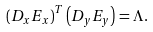<formula> <loc_0><loc_0><loc_500><loc_500>\left ( { D } _ { x } { E } _ { x } \right ) ^ { T } \left ( { D } _ { y } { E } _ { y } \right ) = { \Lambda } .</formula> 